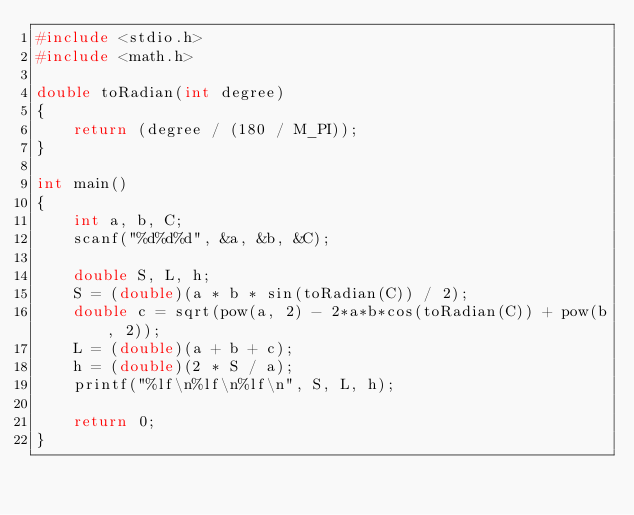<code> <loc_0><loc_0><loc_500><loc_500><_C_>#include <stdio.h>
#include <math.h>

double toRadian(int degree)
{
    return (degree / (180 / M_PI));
}

int main()
{
    int a, b, C;
    scanf("%d%d%d", &a, &b, &C);

    double S, L, h;
    S = (double)(a * b * sin(toRadian(C)) / 2);
    double c = sqrt(pow(a, 2) - 2*a*b*cos(toRadian(C)) + pow(b, 2));
    L = (double)(a + b + c);
    h = (double)(2 * S / a);
    printf("%lf\n%lf\n%lf\n", S, L, h);

    return 0;
}
</code> 